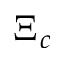<formula> <loc_0><loc_0><loc_500><loc_500>\Xi _ { c }</formula> 